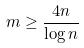<formula> <loc_0><loc_0><loc_500><loc_500>m \geq \frac { 4 n } { \log n }</formula> 